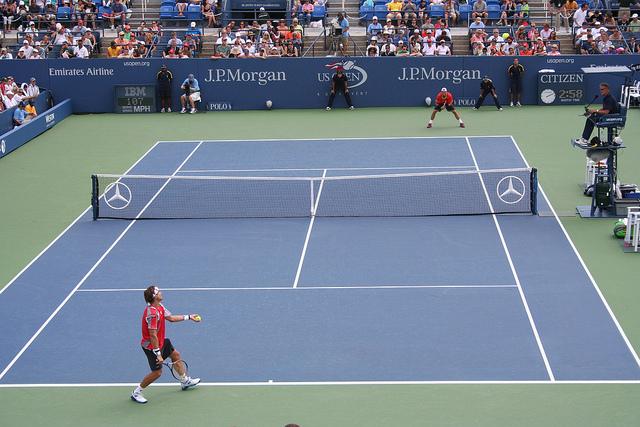Are these the championships?
Concise answer only. Yes. What are these people playing?
Answer briefly. Tennis. Which airline is advertised?
Concise answer only. Emirates. 